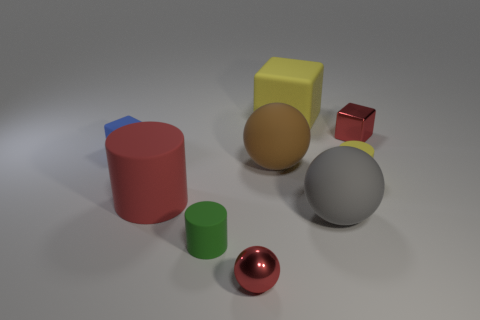Are there any other things that have the same shape as the brown thing?
Your answer should be compact. Yes. There is another small thing that is the same shape as the tiny green matte thing; what color is it?
Ensure brevity in your answer.  Yellow. There is a small matte cylinder to the left of the small ball; is it the same color as the small cube that is left of the small yellow rubber object?
Provide a short and direct response. No. Is the number of matte objects that are in front of the big yellow object greater than the number of big yellow matte things?
Offer a terse response. Yes. What number of other objects are the same size as the yellow matte cylinder?
Offer a very short reply. 4. How many things are both behind the red rubber cylinder and in front of the blue thing?
Your answer should be very brief. 2. Is the material of the block right of the yellow rubber cube the same as the large red object?
Your answer should be compact. No. What shape is the red shiny thing right of the metallic object in front of the small blue rubber cube that is behind the large brown rubber thing?
Provide a short and direct response. Cube. Is the number of tiny green matte cylinders that are on the right side of the big red matte cylinder the same as the number of tiny blue rubber blocks left of the tiny blue matte object?
Your response must be concise. No. What color is the other shiny cube that is the same size as the blue block?
Offer a terse response. Red. 